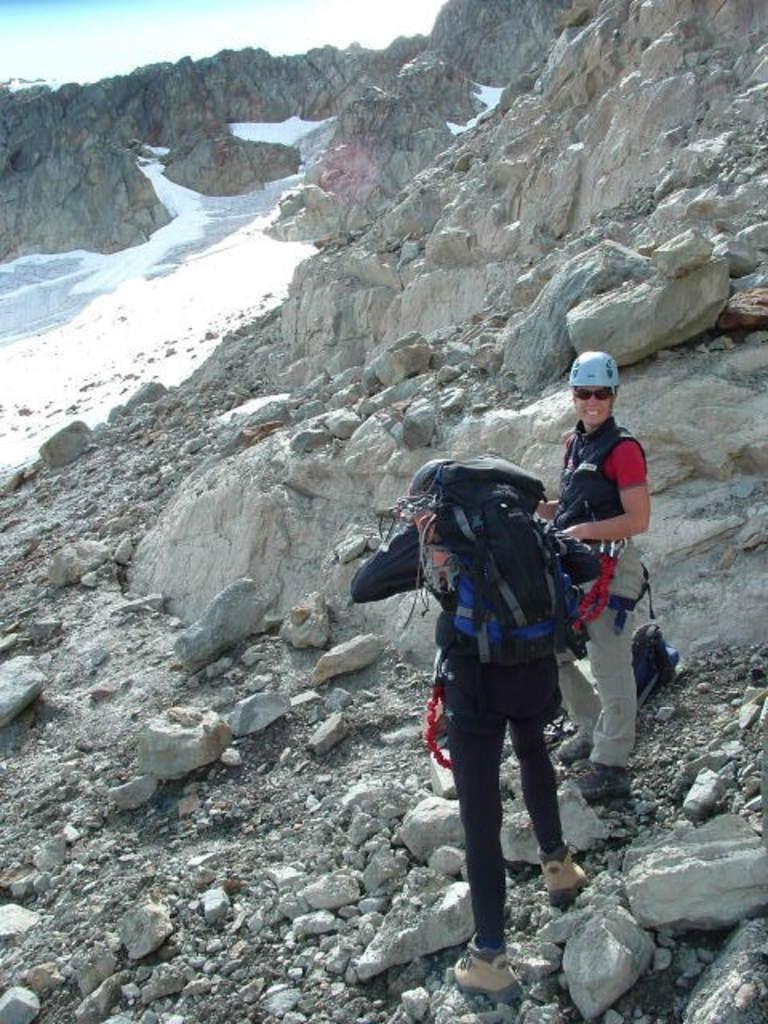Describe this image in one or two sentences. In this picture we can see couple of people, beside them we can find few rocks and the left side person is carrying a bag. 